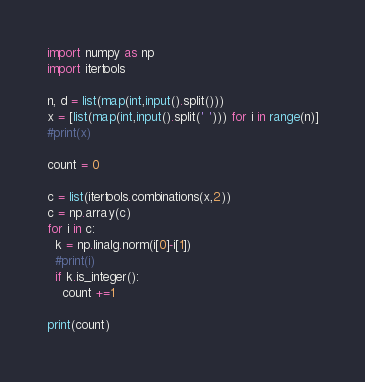Convert code to text. <code><loc_0><loc_0><loc_500><loc_500><_Python_>import numpy as np
import itertools

n, d = list(map(int,input().split()))
x = [list(map(int,input().split(' '))) for i in range(n)]
#print(x)

count = 0

c = list(itertools.combinations(x,2))
c = np.array(c)
for i in c:
  k = np.linalg.norm(i[0]-i[1])
  #print(i)
  if k.is_integer():
    count +=1

print(count)  </code> 